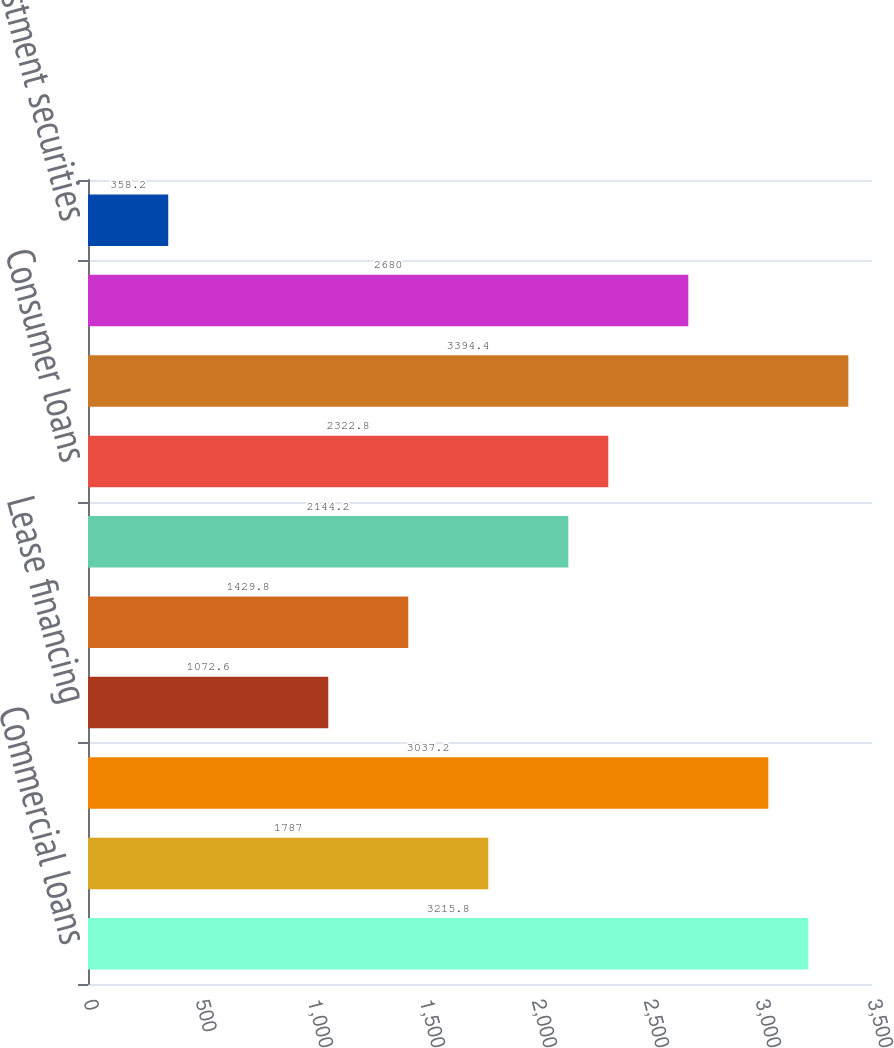Convert chart. <chart><loc_0><loc_0><loc_500><loc_500><bar_chart><fcel>Commercial loans<fcel>Real estate construction loans<fcel>Commercial mortgage loans<fcel>Lease financing<fcel>International loans<fcel>Residential mortgage loans<fcel>Consumer loans<fcel>Total loans (a) (b)<fcel>Mortgage-backed securities<fcel>Other investment securities<nl><fcel>3215.8<fcel>1787<fcel>3037.2<fcel>1072.6<fcel>1429.8<fcel>2144.2<fcel>2322.8<fcel>3394.4<fcel>2680<fcel>358.2<nl></chart> 